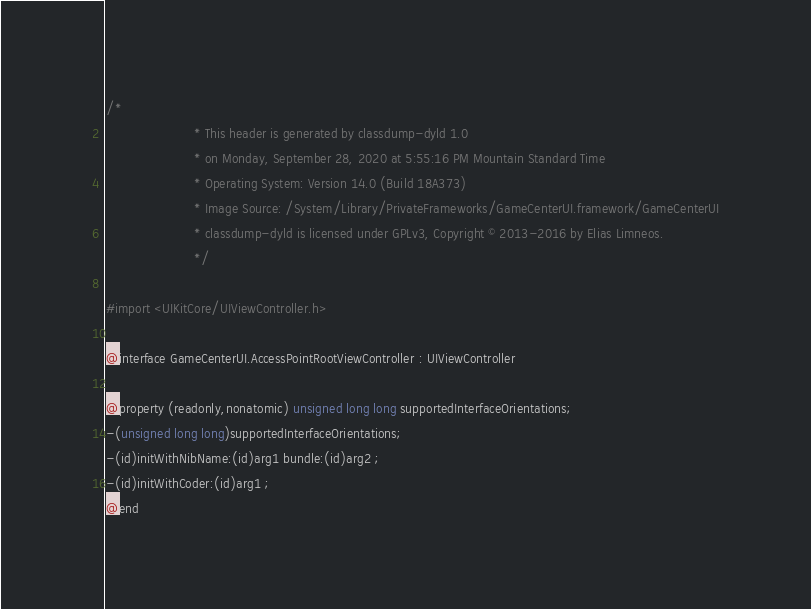Convert code to text. <code><loc_0><loc_0><loc_500><loc_500><_C_>/*
                       * This header is generated by classdump-dyld 1.0
                       * on Monday, September 28, 2020 at 5:55:16 PM Mountain Standard Time
                       * Operating System: Version 14.0 (Build 18A373)
                       * Image Source: /System/Library/PrivateFrameworks/GameCenterUI.framework/GameCenterUI
                       * classdump-dyld is licensed under GPLv3, Copyright © 2013-2016 by Elias Limneos.
                       */

#import <UIKitCore/UIViewController.h>

@interface GameCenterUI.AccessPointRootViewController : UIViewController

@property (readonly,nonatomic) unsigned long long supportedInterfaceOrientations; 
-(unsigned long long)supportedInterfaceOrientations;
-(id)initWithNibName:(id)arg1 bundle:(id)arg2 ;
-(id)initWithCoder:(id)arg1 ;
@end

</code> 